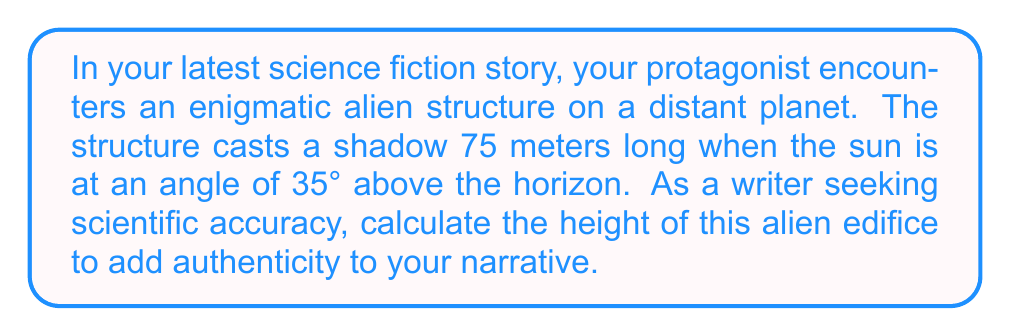Teach me how to tackle this problem. To solve this problem, we'll use trigonometry, specifically the tangent function. Let's break it down step by step:

1) First, let's visualize the scenario:

[asy]
import geometry;

size(200);
pair A = (0,0), B = (75,0), C = (0,52.5);
draw(A--B--C--A);
draw((-10,0)--(85,0), arrow=Arrow(TeXHead));
draw((0,-5)--(0,60), arrow=Arrow(TeXHead));
label("75 m", (37.5,-5), S);
label("h", (-5,26.25), W);
label("35°", (5,5), NE);
label("Sun", (80,50));
draw((75,0)--(85,15), arrow=Arrow(TeXHead));
[/asy]

2) In this right-angled triangle, we know:
   - The adjacent side (shadow length) = 75 meters
   - The angle of elevation of the sun = 35°
   - We need to find the opposite side (height of the structure)

3) The tangent of an angle in a right triangle is the ratio of the opposite side to the adjacent side:

   $$\tan(\theta) = \frac{\text{opposite}}{\text{adjacent}}$$

4) In our case:

   $$\tan(35°) = \frac{\text{height}}{75}$$

5) To find the height, we multiply both sides by 75:

   $$75 \cdot \tan(35°) = \text{height}$$

6) Now we can calculate:

   $$\text{height} = 75 \cdot \tan(35°) \approx 75 \cdot 0.7002 \approx 52.5152 \text{ meters}$$

7) Rounding to two decimal places for practical use in the story:

   $$\text{height} \approx 52.52 \text{ meters}$$
Answer: The height of the alien structure is approximately 52.52 meters. 